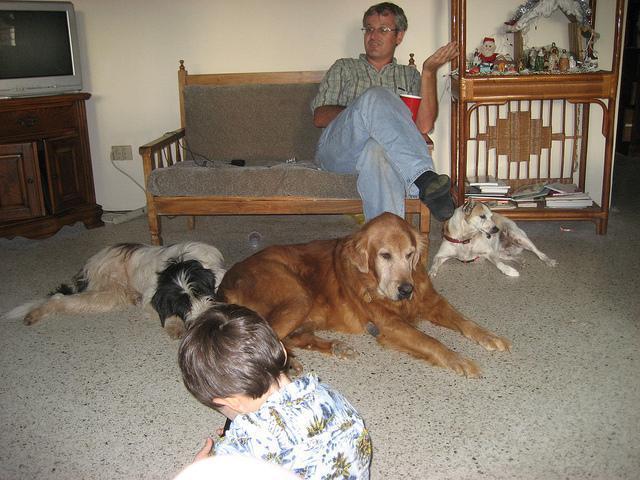How many dogs are relaxing?
Give a very brief answer. 3. How many dogs are in the photo?
Give a very brief answer. 3. How many different animals are in the picture?
Give a very brief answer. 3. How many people are there?
Give a very brief answer. 2. How many dogs are there?
Give a very brief answer. 3. 